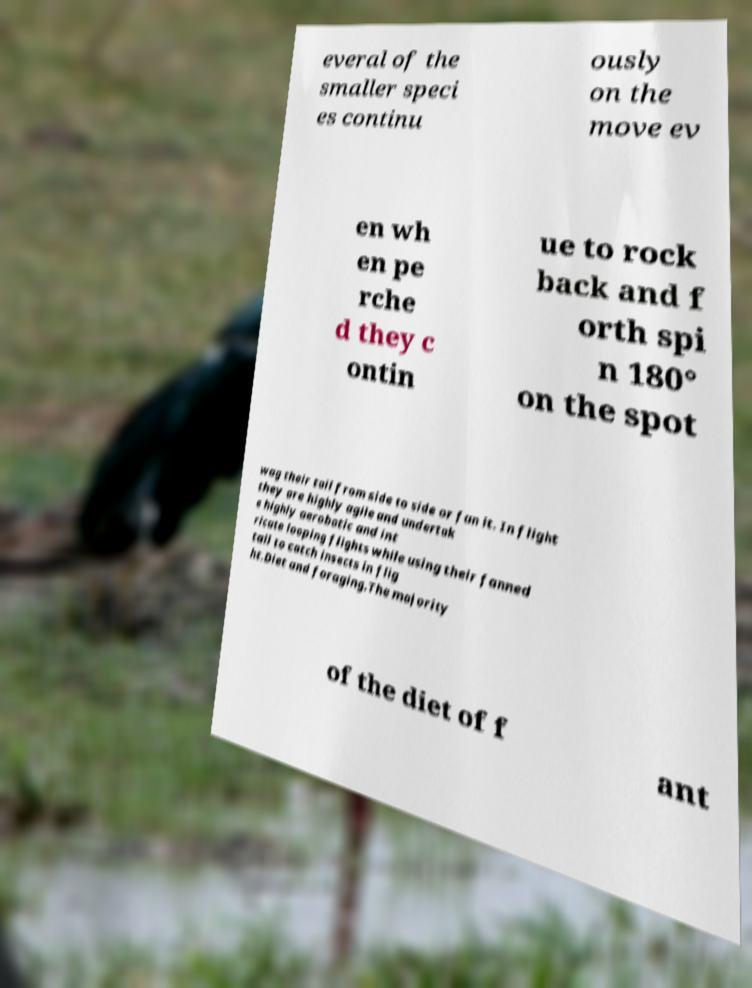Please read and relay the text visible in this image. What does it say? everal of the smaller speci es continu ously on the move ev en wh en pe rche d they c ontin ue to rock back and f orth spi n 180° on the spot wag their tail from side to side or fan it. In flight they are highly agile and undertak e highly aerobatic and int ricate looping flights while using their fanned tail to catch insects in flig ht.Diet and foraging.The majority of the diet of f ant 